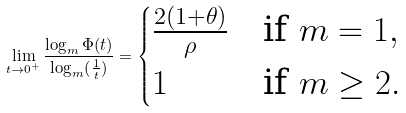<formula> <loc_0><loc_0><loc_500><loc_500>\lim _ { t \to 0 ^ { + } } \frac { \log _ { m } \Phi ( t ) } { \log _ { m } ( \frac { 1 } { t } ) } = \begin{cases} \frac { 2 ( 1 + \theta ) } { \rho } & \text {if $m=1$} , \\ 1 & \text {if $m\geq 2$} . \end{cases}</formula> 